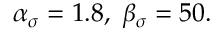Convert formula to latex. <formula><loc_0><loc_0><loc_500><loc_500>\begin{array} { r } { \alpha _ { \sigma } = 1 . 8 , \ \beta _ { \sigma } = 5 0 . } \end{array}</formula> 